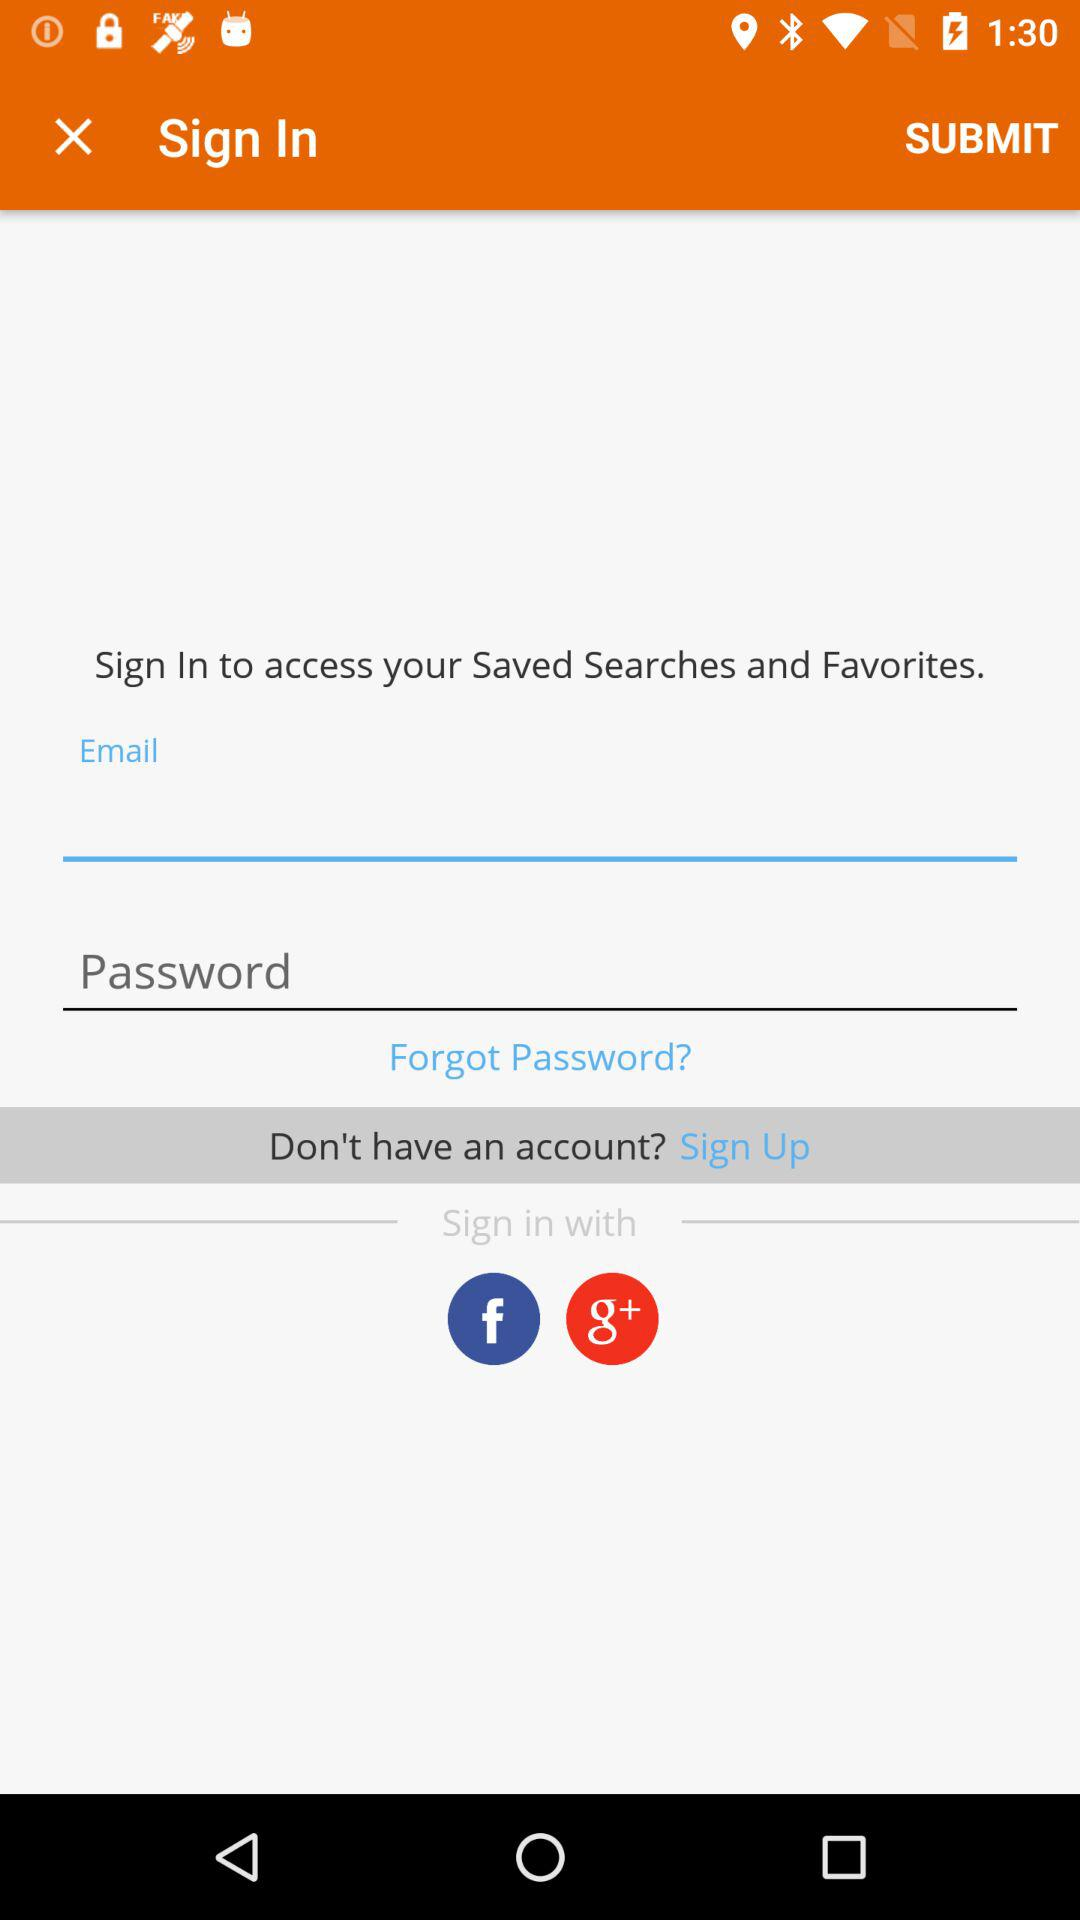How many input fields are there for signing in?
Answer the question using a single word or phrase. 2 